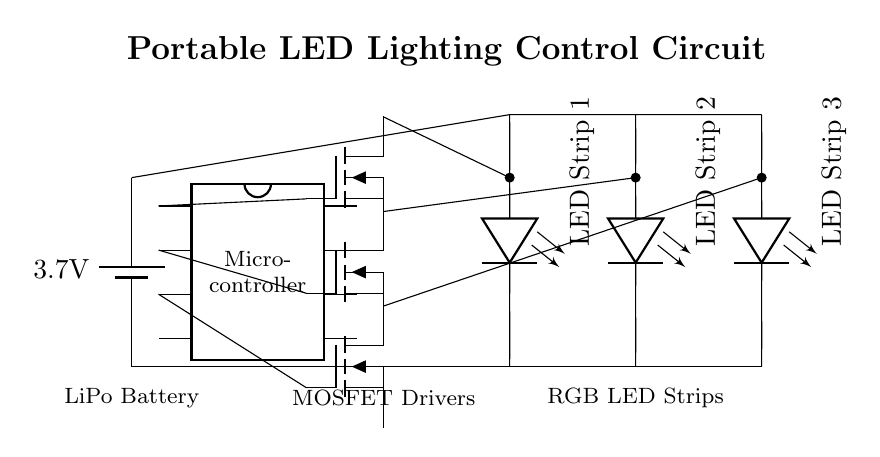What is the power supply voltage in this circuit? The voltage is 3.7 volts, as indicated by the battery symbol in the circuit. This point provides the circuit with its operating voltage.
Answer: 3.7 volts What components control the LED strips? The components controlling the LED strips are MOSFET drivers, which act as switches to control the current flowing through each LED strip based on signals from the microcontroller.
Answer: MOSFET drivers How many LED strips are connected in this circuit? There are three LED strips connected, as shown by the three separate lines labeled LED Strip 1, LED Strip 2, and LED Strip 3.
Answer: Three Which component is responsible for processing control signals? The microcontroller is responsible for processing control signals, as it sends gate signals to the MOSFET drivers to control the LED strips' illumination.
Answer: Microcontroller How do the MOSFET drivers connect to the battery? The MOSFET drivers have a common connection point to the battery, where the source terminals are connected to the ground of the battery, allowing them to switch the LED strips on and off effectively.
Answer: Common connection to battery ground What is the type of battery used in this circuit? The type of battery used is a Lithium Polymer (LiPo) battery, denoted by the labeling near the battery symbol.
Answer: Lithium Polymer (LiPo) What is the purpose of the gate pins in this circuit? The gate pins of the MOSFET drivers are used to receive control signals from the microcontroller, determining the switching state of each MOSFET which in turn controls the brightness of the LED strips.
Answer: Control signals 